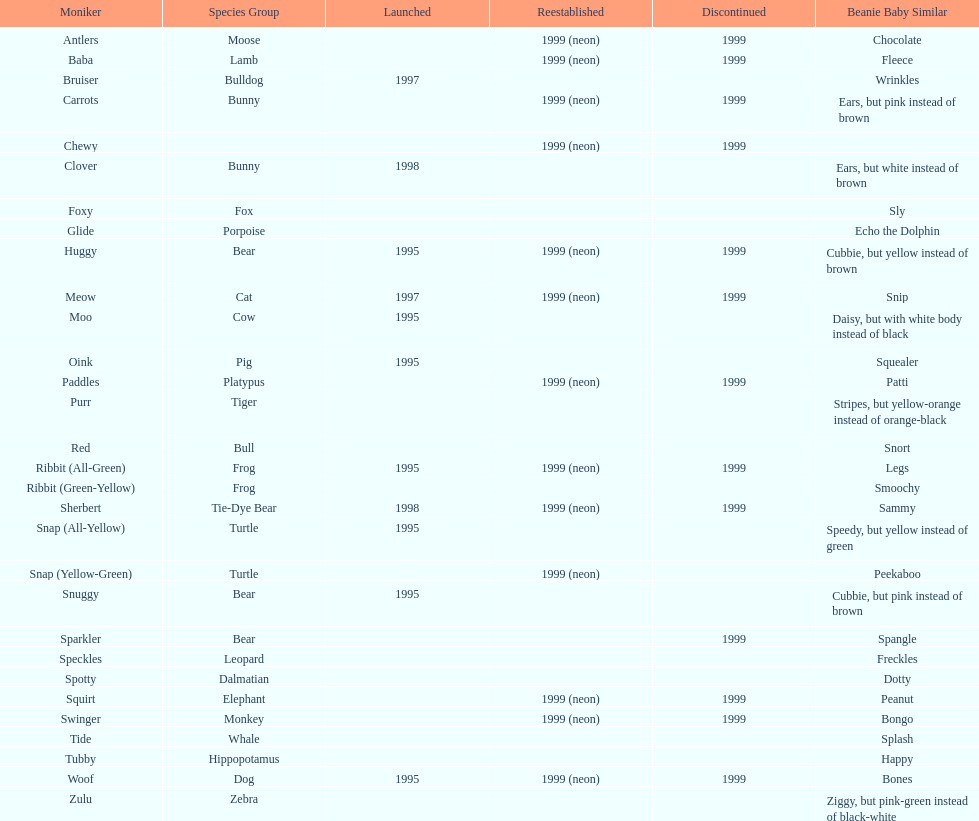Which is the only pillow pal without a listed animal type? Chewy. 